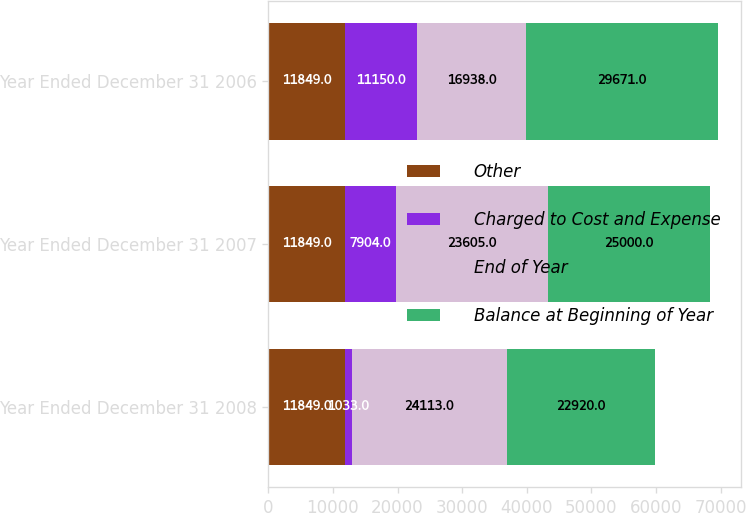Convert chart to OTSL. <chart><loc_0><loc_0><loc_500><loc_500><stacked_bar_chart><ecel><fcel>Year Ended December 31 2008<fcel>Year Ended December 31 2007<fcel>Year Ended December 31 2006<nl><fcel>Other<fcel>11849<fcel>11849<fcel>11849<nl><fcel>Charged to Cost and Expense<fcel>1033<fcel>7904<fcel>11150<nl><fcel>End of Year<fcel>24113<fcel>23605<fcel>16938<nl><fcel>Balance at Beginning of Year<fcel>22920<fcel>25000<fcel>29671<nl></chart> 